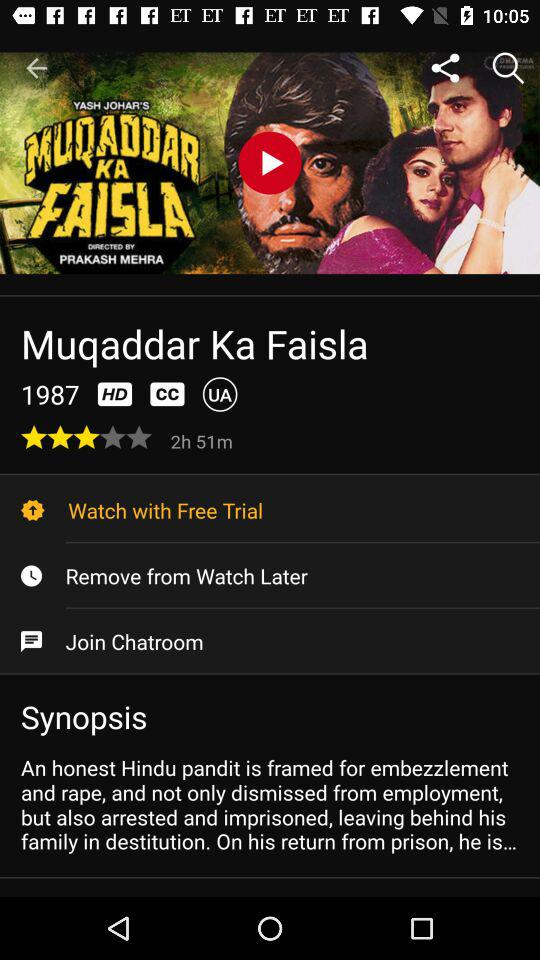In what year was the movie released? The movie was released in 1987. 